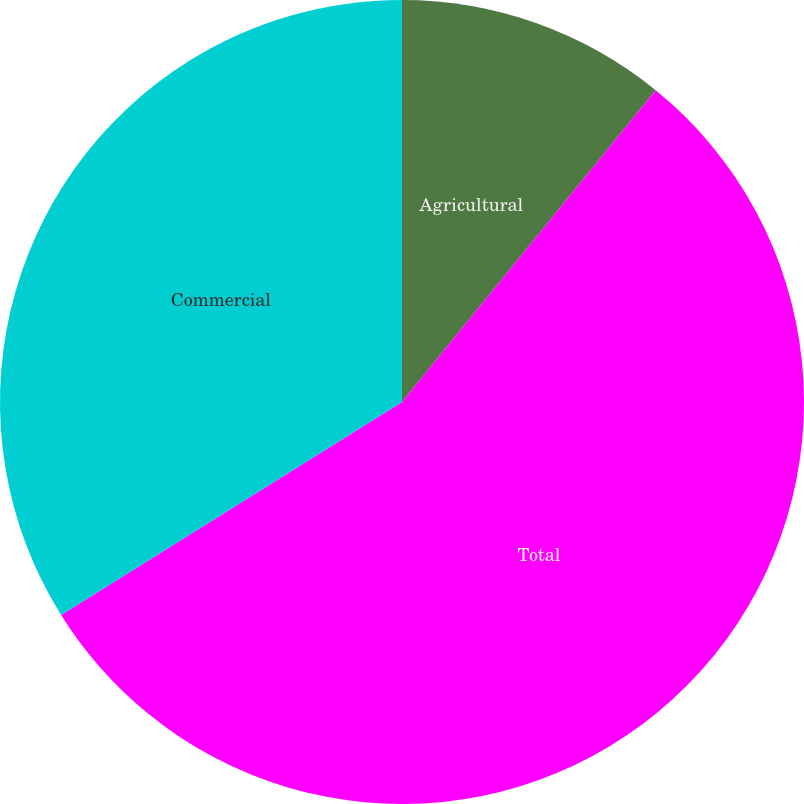Convert chart to OTSL. <chart><loc_0><loc_0><loc_500><loc_500><pie_chart><fcel>Agricultural<fcel>Total<fcel>Commercial<nl><fcel>10.87%<fcel>55.24%<fcel>33.89%<nl></chart> 